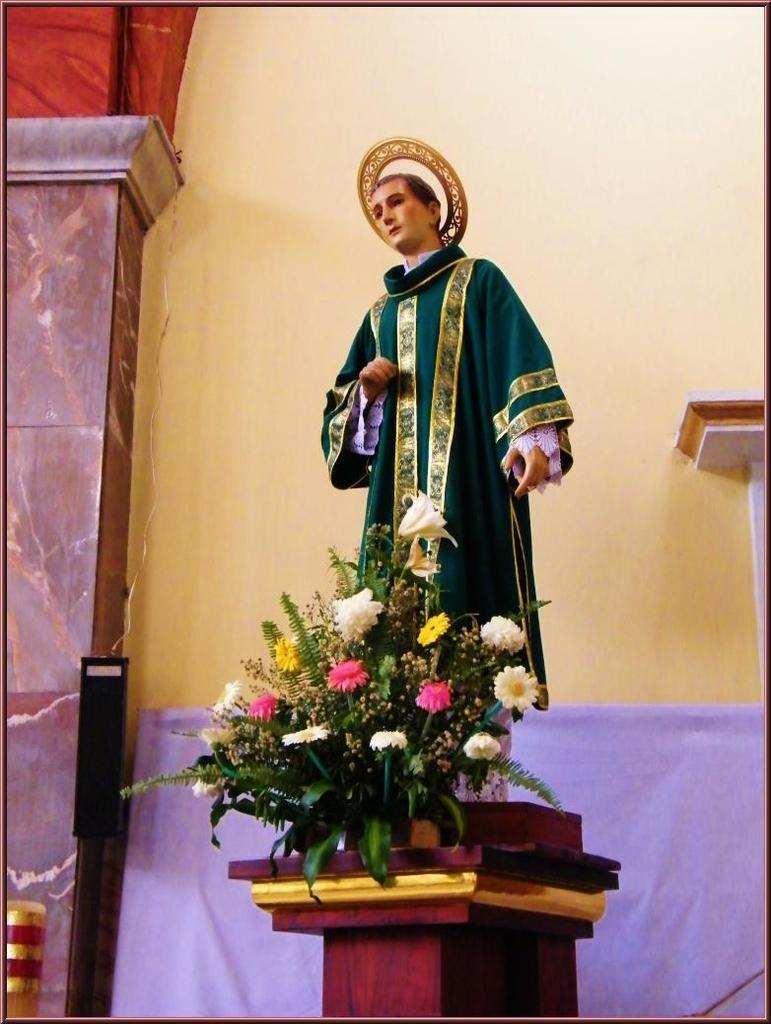What is the main subject in the image? There is a sculpture in the image. What is placed in front of the sculpture? There is a bouquet on a stand in front of the sculpture. What architectural feature can be seen in the image? There is a pillar in the image. What is connected to a wire in the image? A speaker is connected to a wire in the image. What is the background of the image made up of? There is a wall in the image. What type of beef is being served at the feast in the image? There is no feast or beef present in the image; it features a sculpture, bouquet, pillar, speaker, and wall. 